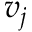<formula> <loc_0><loc_0><loc_500><loc_500>v _ { j }</formula> 